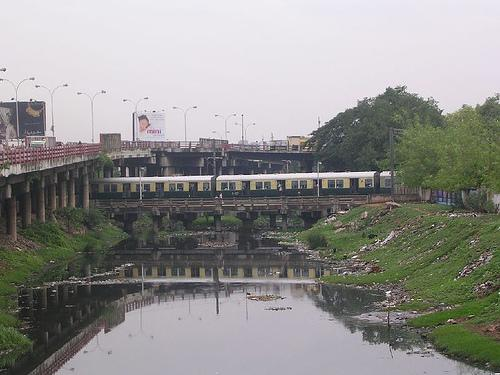What is the problem in this area? Please explain your reasoning. water pollution. There is a lot of garbage in the water. 